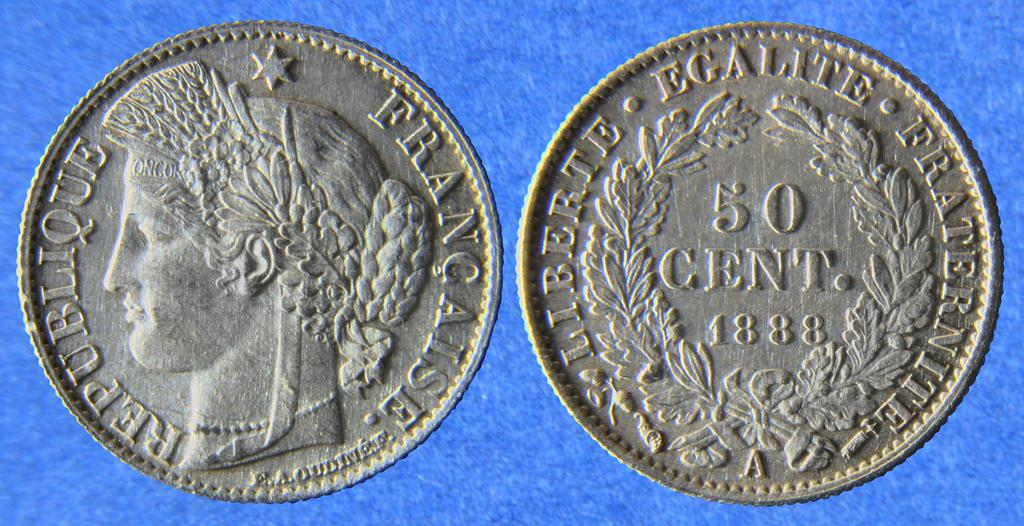<image>
Offer a succinct explanation of the picture presented. A 50 cent coin that was minted in 1888. 